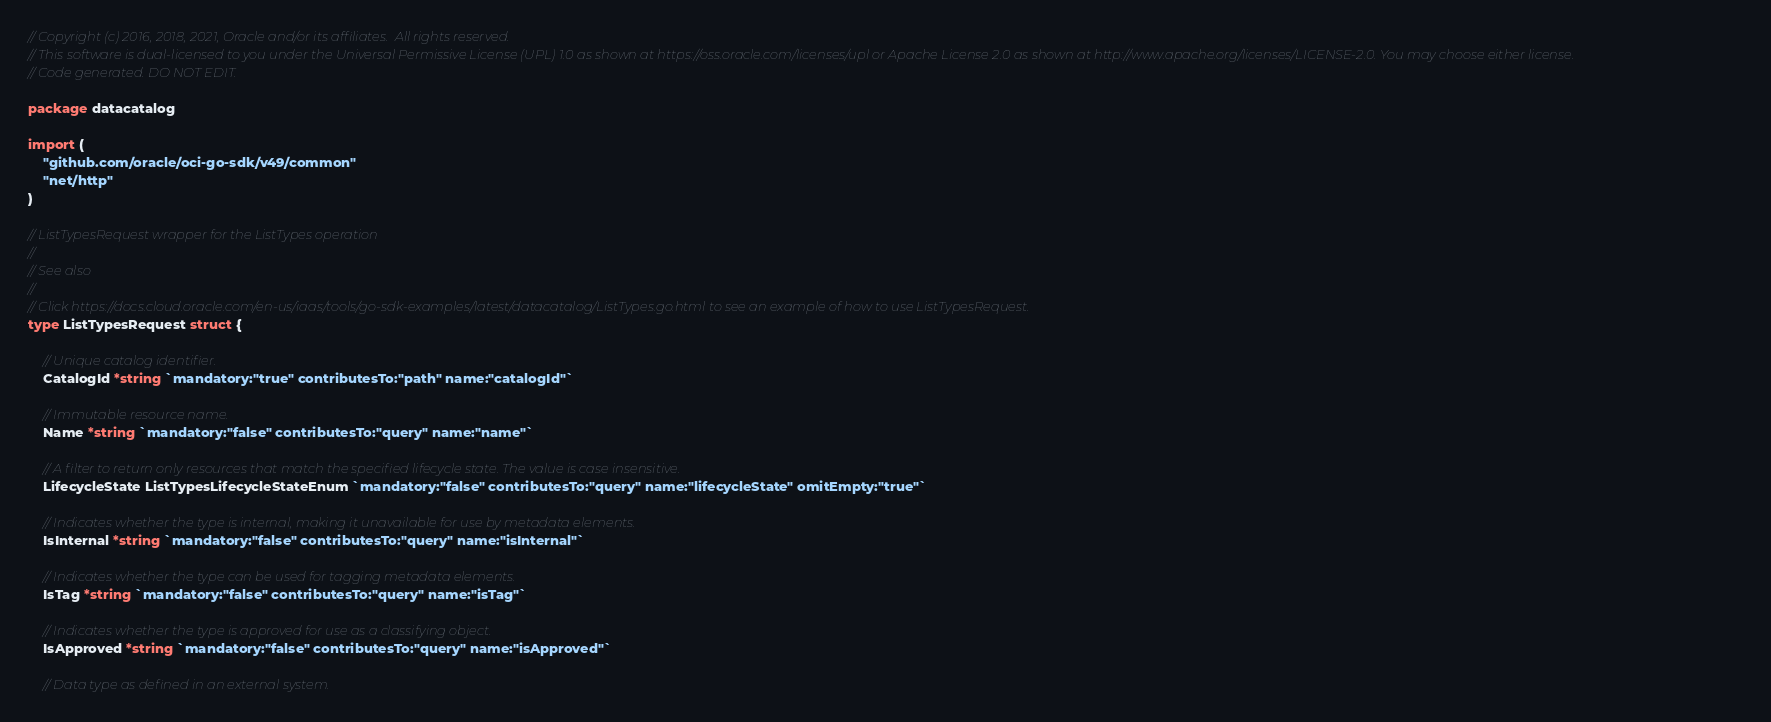<code> <loc_0><loc_0><loc_500><loc_500><_Go_>// Copyright (c) 2016, 2018, 2021, Oracle and/or its affiliates.  All rights reserved.
// This software is dual-licensed to you under the Universal Permissive License (UPL) 1.0 as shown at https://oss.oracle.com/licenses/upl or Apache License 2.0 as shown at http://www.apache.org/licenses/LICENSE-2.0. You may choose either license.
// Code generated. DO NOT EDIT.

package datacatalog

import (
	"github.com/oracle/oci-go-sdk/v49/common"
	"net/http"
)

// ListTypesRequest wrapper for the ListTypes operation
//
// See also
//
// Click https://docs.cloud.oracle.com/en-us/iaas/tools/go-sdk-examples/latest/datacatalog/ListTypes.go.html to see an example of how to use ListTypesRequest.
type ListTypesRequest struct {

	// Unique catalog identifier.
	CatalogId *string `mandatory:"true" contributesTo:"path" name:"catalogId"`

	// Immutable resource name.
	Name *string `mandatory:"false" contributesTo:"query" name:"name"`

	// A filter to return only resources that match the specified lifecycle state. The value is case insensitive.
	LifecycleState ListTypesLifecycleStateEnum `mandatory:"false" contributesTo:"query" name:"lifecycleState" omitEmpty:"true"`

	// Indicates whether the type is internal, making it unavailable for use by metadata elements.
	IsInternal *string `mandatory:"false" contributesTo:"query" name:"isInternal"`

	// Indicates whether the type can be used for tagging metadata elements.
	IsTag *string `mandatory:"false" contributesTo:"query" name:"isTag"`

	// Indicates whether the type is approved for use as a classifying object.
	IsApproved *string `mandatory:"false" contributesTo:"query" name:"isApproved"`

	// Data type as defined in an external system.</code> 